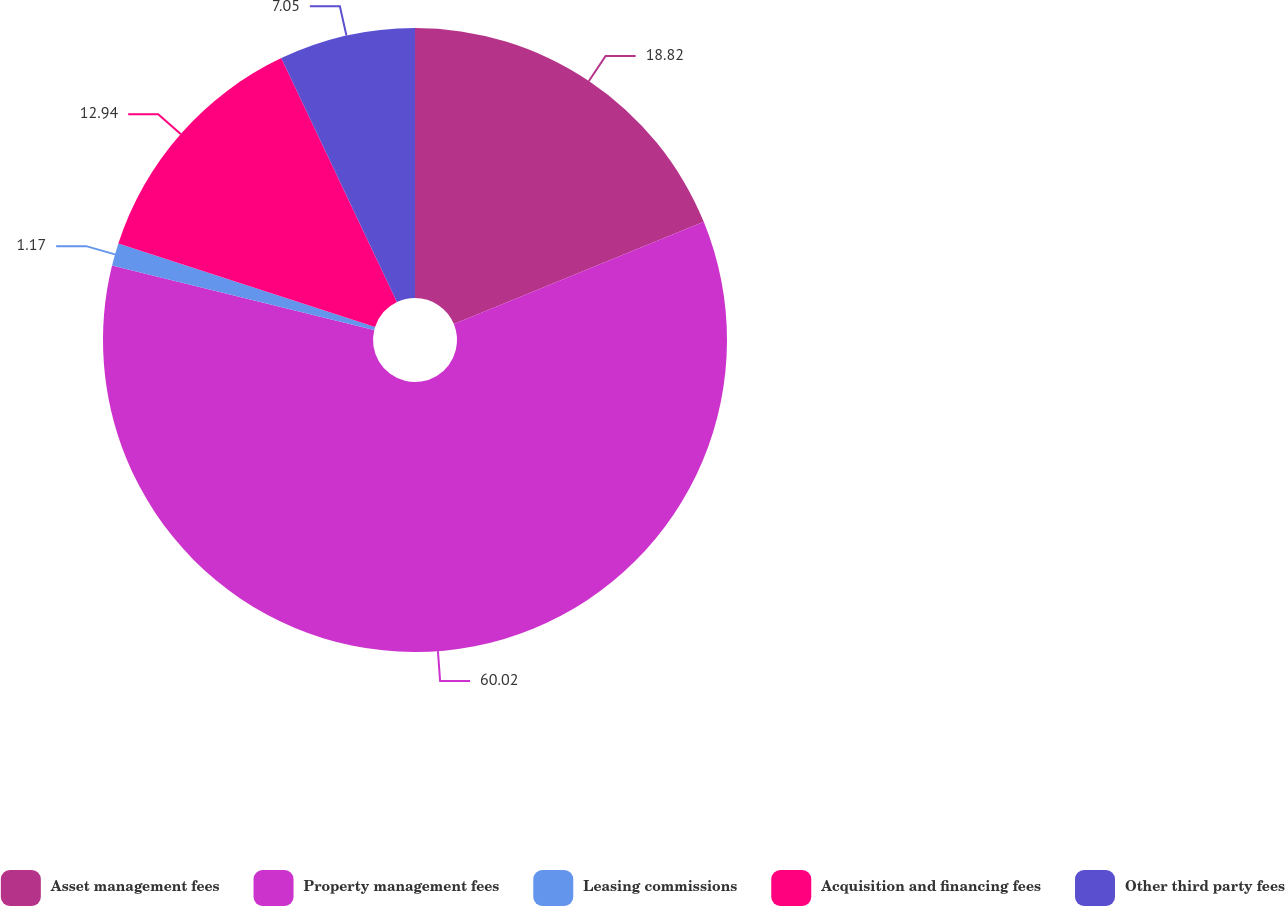Convert chart to OTSL. <chart><loc_0><loc_0><loc_500><loc_500><pie_chart><fcel>Asset management fees<fcel>Property management fees<fcel>Leasing commissions<fcel>Acquisition and financing fees<fcel>Other third party fees<nl><fcel>18.82%<fcel>60.02%<fcel>1.17%<fcel>12.94%<fcel>7.05%<nl></chart> 